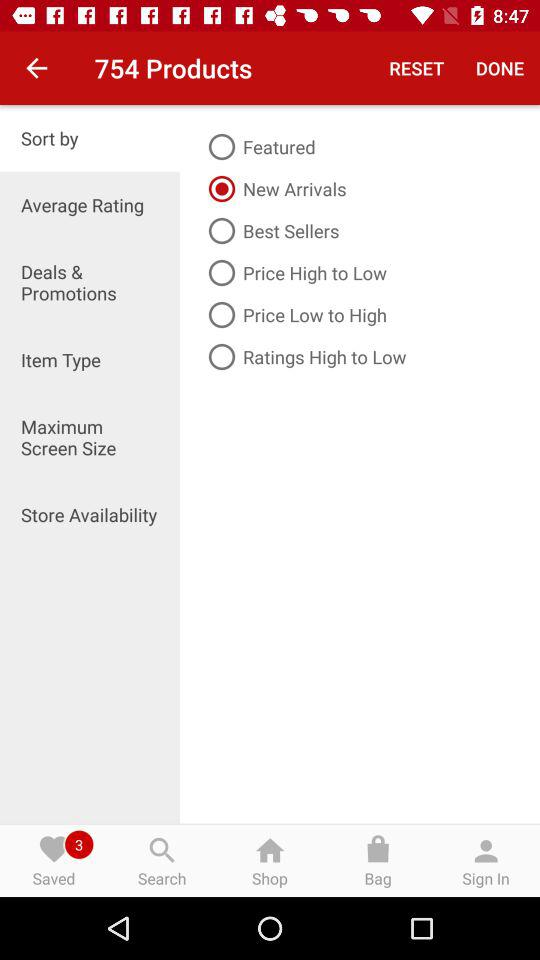Which option is selected? The selected options are "Sort by" and "New Arrivals". 